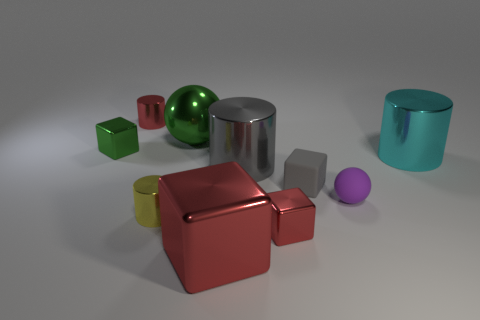Subtract all big blocks. How many blocks are left? 3 Subtract 3 blocks. How many blocks are left? 1 Subtract all green spheres. How many spheres are left? 1 Subtract all blocks. How many objects are left? 6 Subtract all cyan cubes. Subtract all green spheres. How many cubes are left? 4 Subtract all blue spheres. How many red cubes are left? 2 Subtract all green rubber cylinders. Subtract all tiny yellow metallic objects. How many objects are left? 9 Add 4 big blocks. How many big blocks are left? 5 Add 7 small shiny cylinders. How many small shiny cylinders exist? 9 Subtract 1 red cylinders. How many objects are left? 9 